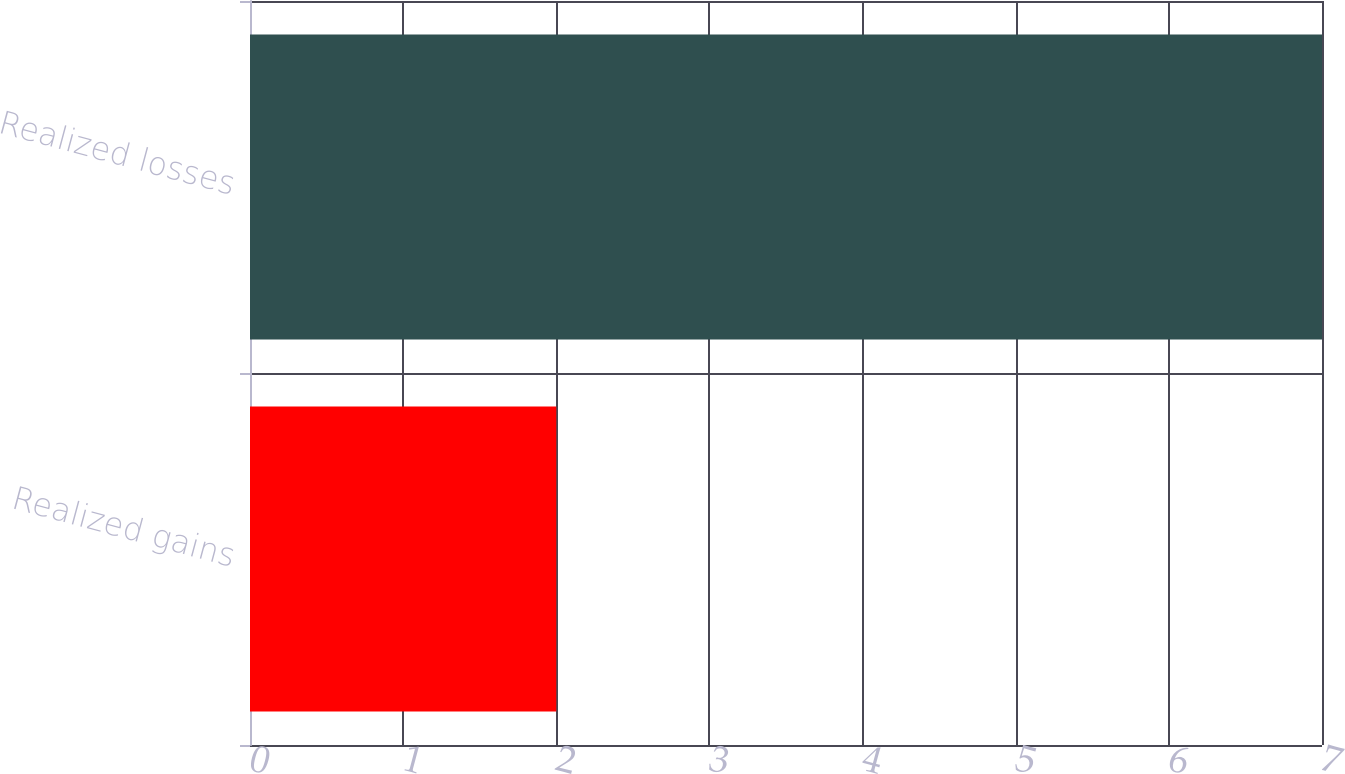Convert chart. <chart><loc_0><loc_0><loc_500><loc_500><bar_chart><fcel>Realized gains<fcel>Realized losses<nl><fcel>2<fcel>7<nl></chart> 